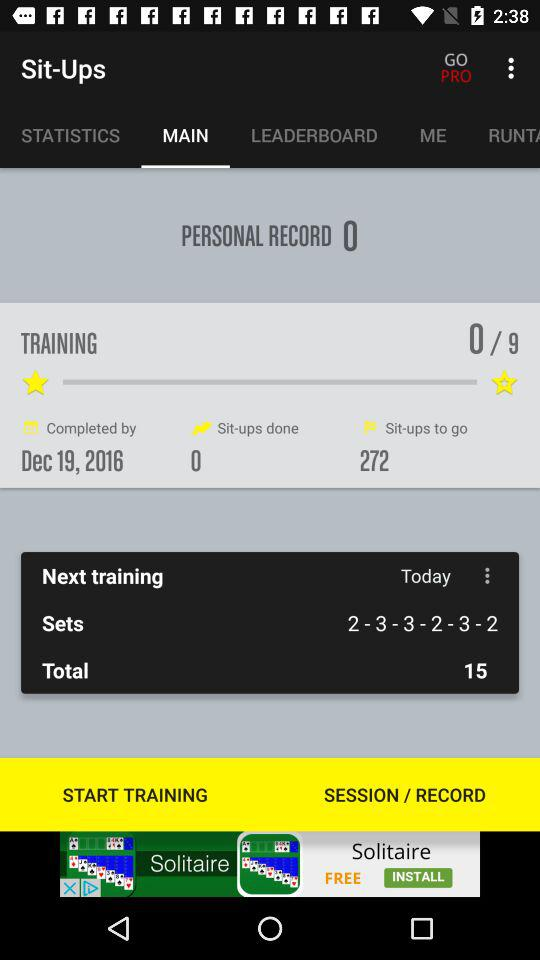How many sit-ups are left to complete?
Answer the question using a single word or phrase. 272 